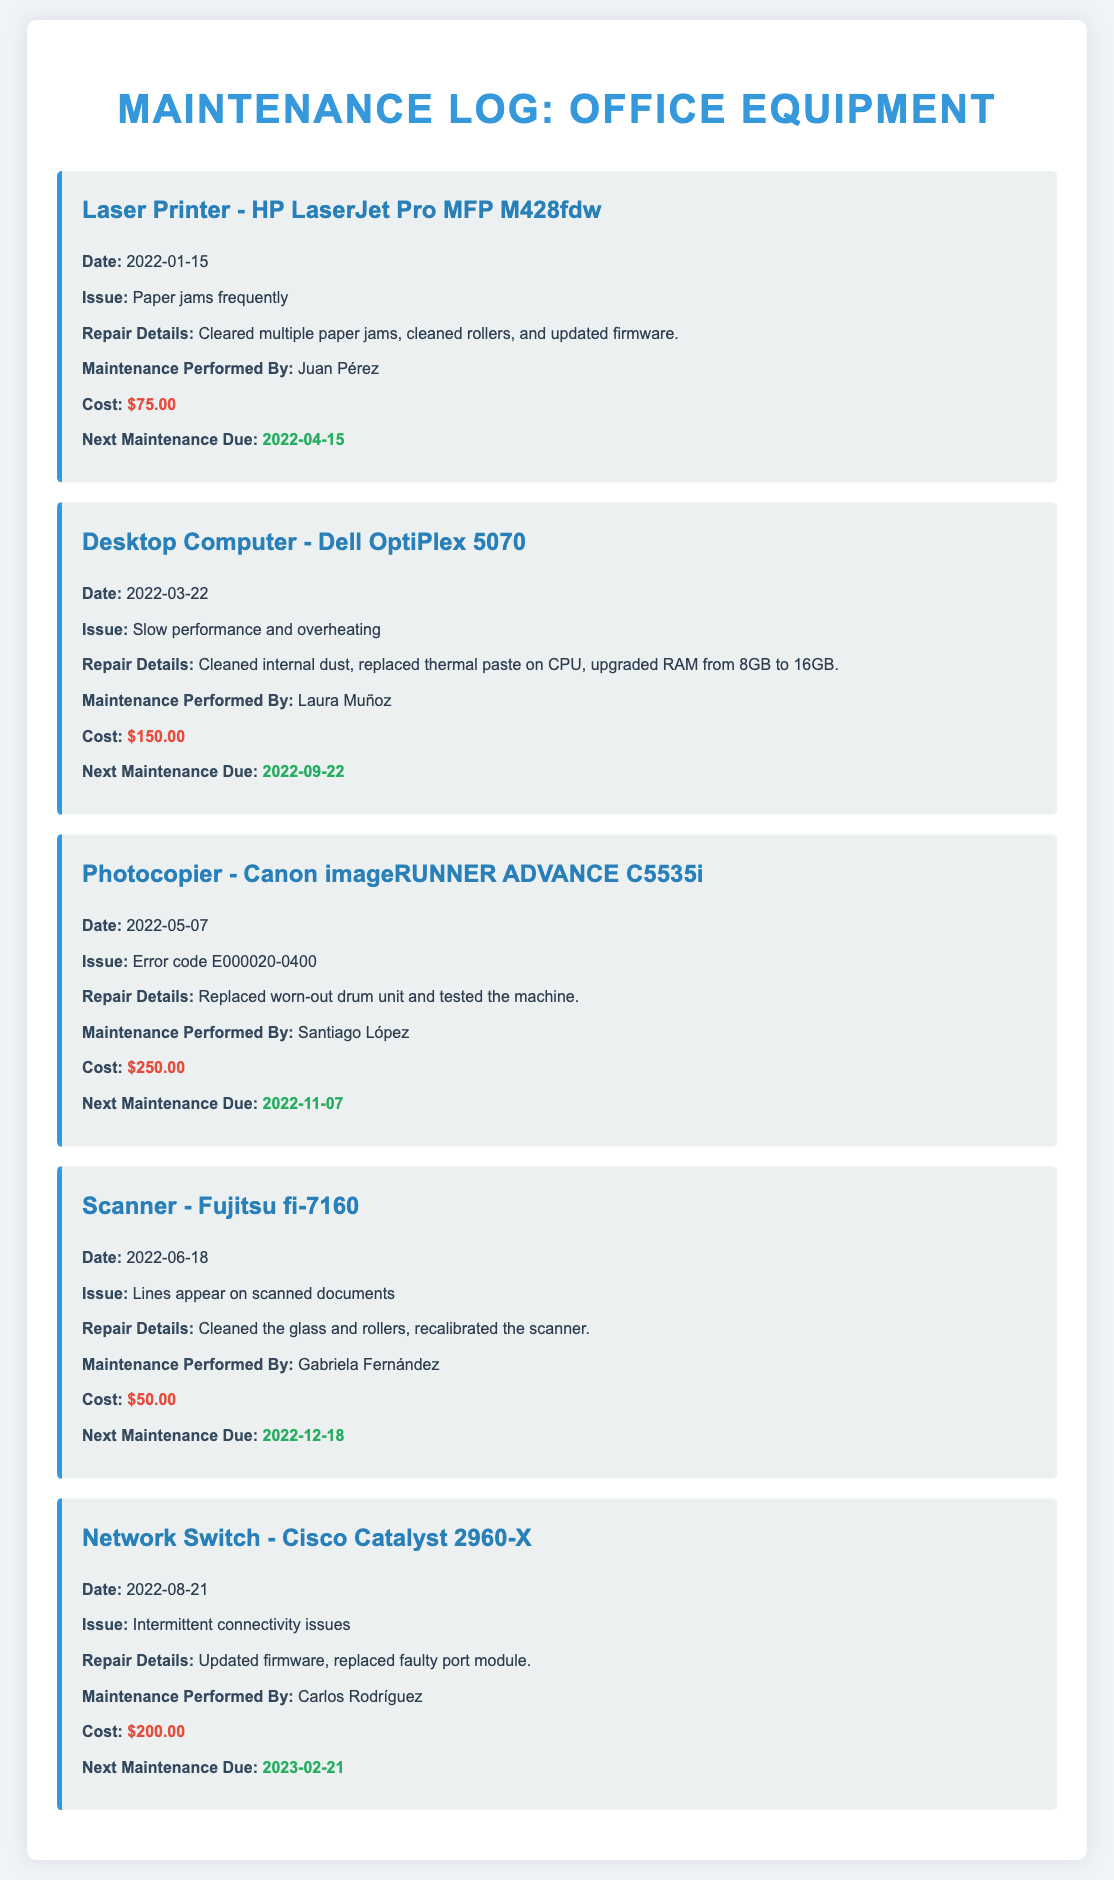What was the first maintenance date for the Laser Printer? The first maintenance date for the Laser Printer - HP LaserJet Pro MFP M428fdw is provided in the log entry, which is 2022-01-15.
Answer: 2022-01-15 Who performed the maintenance on the Desktop Computer? The maintenance performed on the Desktop Computer - Dell OptiPlex 5070 was carried out by Laura Muñoz, as stated in the log entry.
Answer: Laura Muñoz What issue was reported for the Scanner? The issue reported for the Scanner - Fujitsu fi-7160 was lines appearing on scanned documents, which is outlined in the log entry.
Answer: Lines appear on scanned documents What is the cost of the repair for the Photocopier? The cost of the repair for the Photocopier - Canon imageRUNNER ADVANCE C5535i is noted in the log entry as $250.00.
Answer: $250.00 Which equipment had maintenance due next on 2023-02-21? The Network Switch - Cisco Catalyst 2960-X has the next maintenance due on 2023-02-21, as specified in the log entry.
Answer: Cisco Catalyst 2960-X How many pieces of office equipment are listed in the log? The document contains log entries for five pieces of office equipment, which can be counted from the individual entries.
Answer: 5 What was the repair detail for the Laser Printer? The repair details for the Laser Printer - HP LaserJet Pro MFP M428fdw included clearing paper jams, cleaning rollers, and updating firmware, as mentioned in the log.
Answer: Cleared multiple paper jams, cleaned rollers, and updated firmware Which technician is responsible for maintaining the Network Switch? The technician responsible for maintaining the Network Switch - Cisco Catalyst 2960-X is Carlos Rodríguez, according to the log entry.
Answer: Carlos Rodríguez 